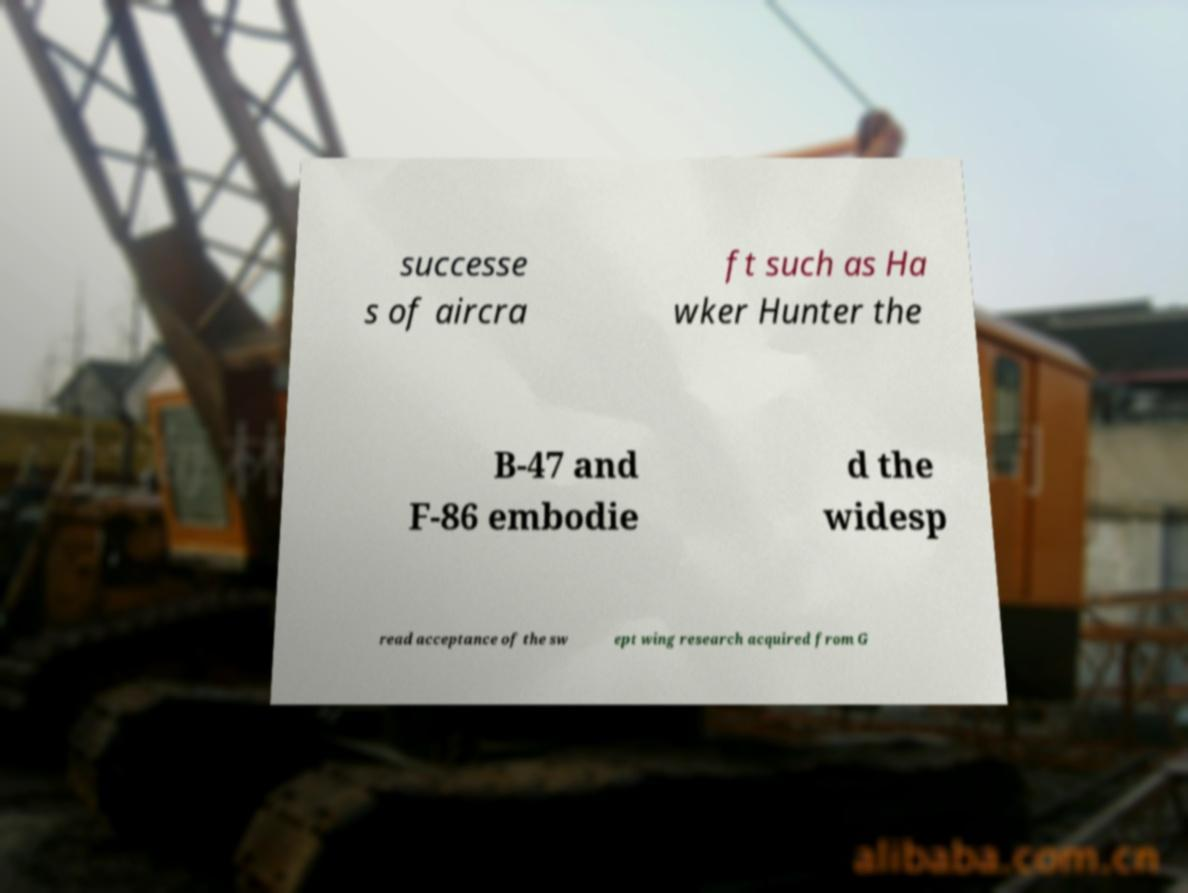There's text embedded in this image that I need extracted. Can you transcribe it verbatim? successe s of aircra ft such as Ha wker Hunter the B-47 and F-86 embodie d the widesp read acceptance of the sw ept wing research acquired from G 